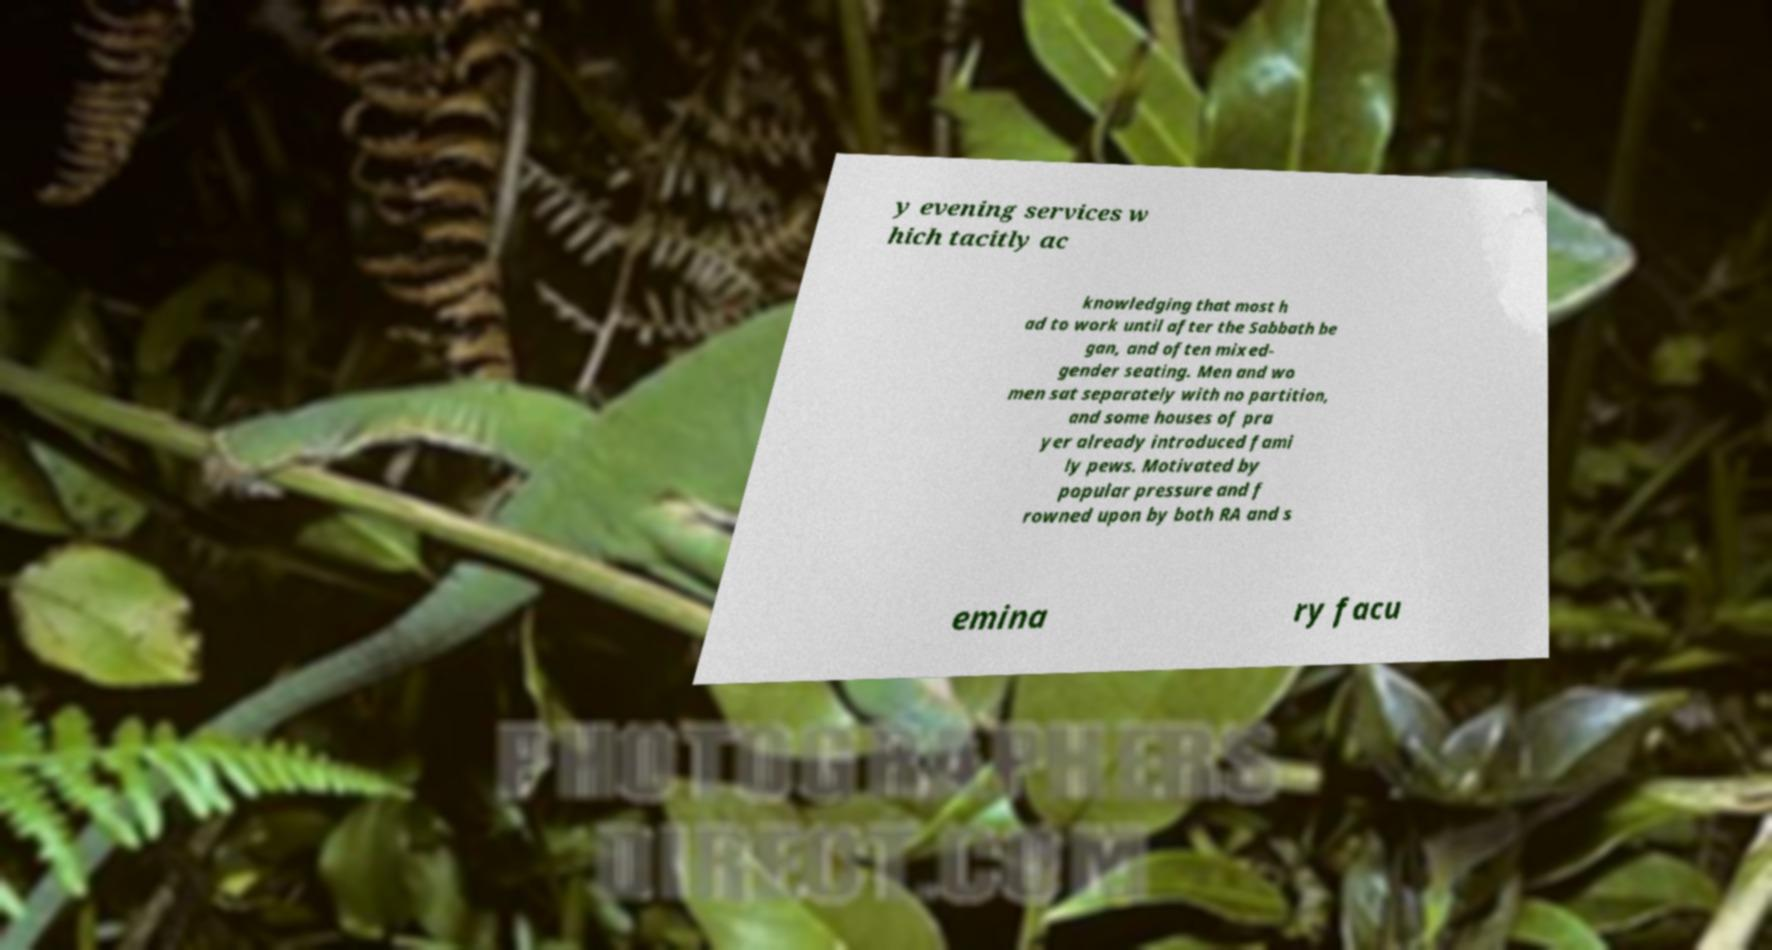Can you accurately transcribe the text from the provided image for me? y evening services w hich tacitly ac knowledging that most h ad to work until after the Sabbath be gan, and often mixed- gender seating. Men and wo men sat separately with no partition, and some houses of pra yer already introduced fami ly pews. Motivated by popular pressure and f rowned upon by both RA and s emina ry facu 